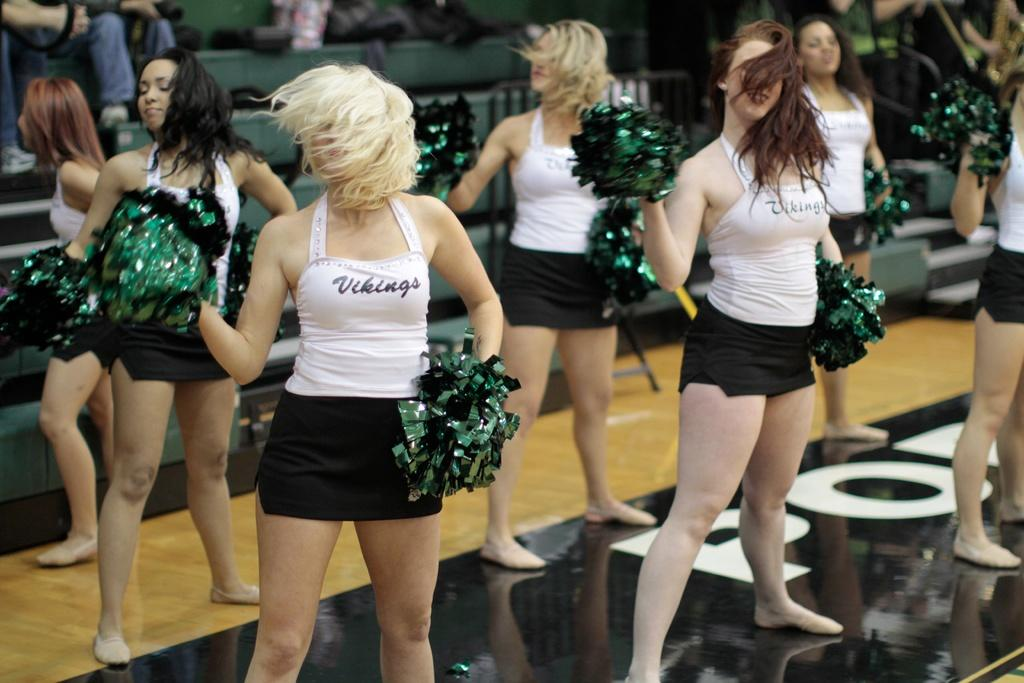<image>
Summarize the visual content of the image. A group of cheerleaders for the Vikings team are performing. 